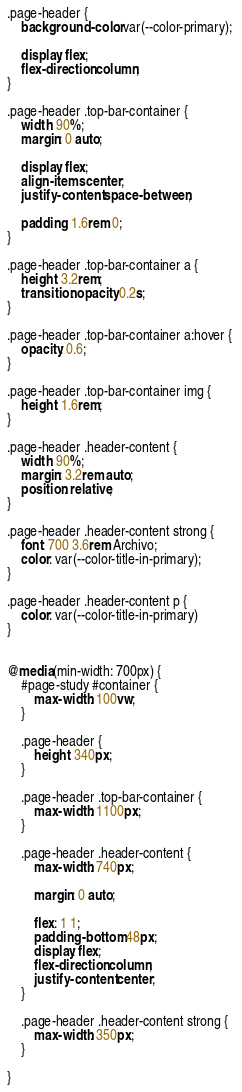Convert code to text. <code><loc_0><loc_0><loc_500><loc_500><_CSS_>.page-header {
    background-color: var(--color-primary); 

    display: flex;
    flex-direction: column;
}

.page-header .top-bar-container {
    width: 90%;
    margin: 0 auto;

    display: flex;
    align-items: center;
    justify-content: space-between;

    padding: 1.6rem 0;
}

.page-header .top-bar-container a {
    height: 3.2rem;
    transition: opacity 0.2s;
}

.page-header .top-bar-container a:hover {
    opacity: 0.6;
}

.page-header .top-bar-container img {
    height: 1.6rem;
}

.page-header .header-content {
    width: 90%;
    margin: 3.2rem auto;
    position: relative;
}

.page-header .header-content strong {
    font: 700 3.6rem Archivo;
    color: var(--color-title-in-primary);
}

.page-header .header-content p {
    color: var(--color-title-in-primary)
}


@media(min-width: 700px) {
    #page-study #container {
        max-width: 100vw;
    }

    .page-header {
        height: 340px;
    }

    .page-header .top-bar-container {
        max-width: 1100px;
    }

    .page-header .header-content {
        max-width: 740px;

        margin: 0 auto;

        flex: 1 1;
        padding-bottom: 48px;
        display: flex;
        flex-direction: column;
        justify-content: center;
    }

    .page-header .header-content strong {
        max-width: 350px;
    }

}</code> 